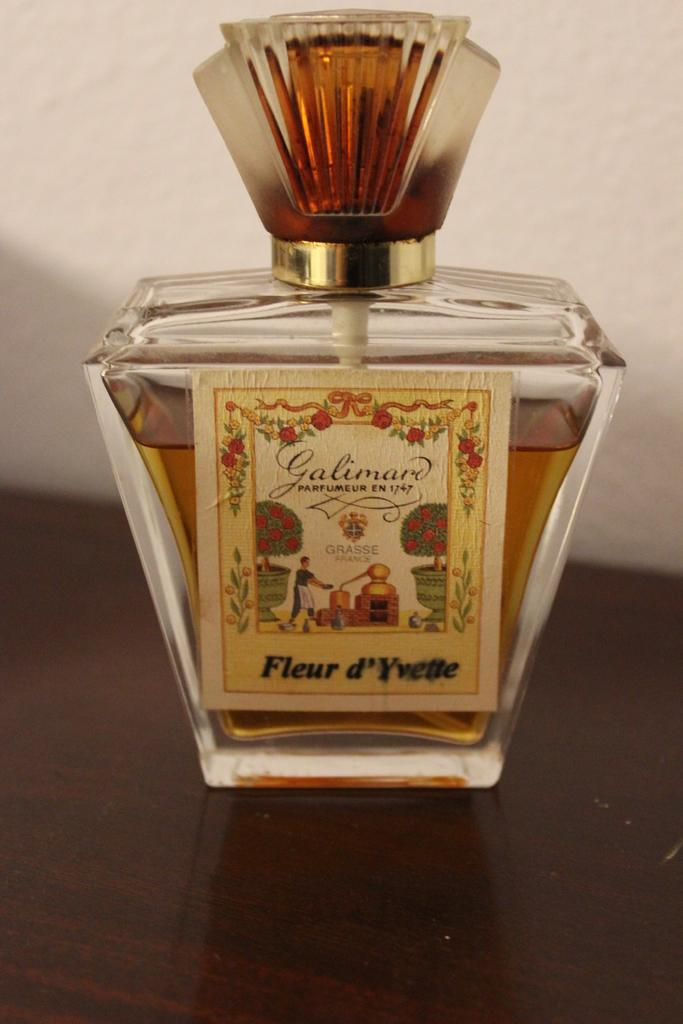<image>
Offer a succinct explanation of the picture presented. A perfume in a nice bottle from the brand Galimar. 